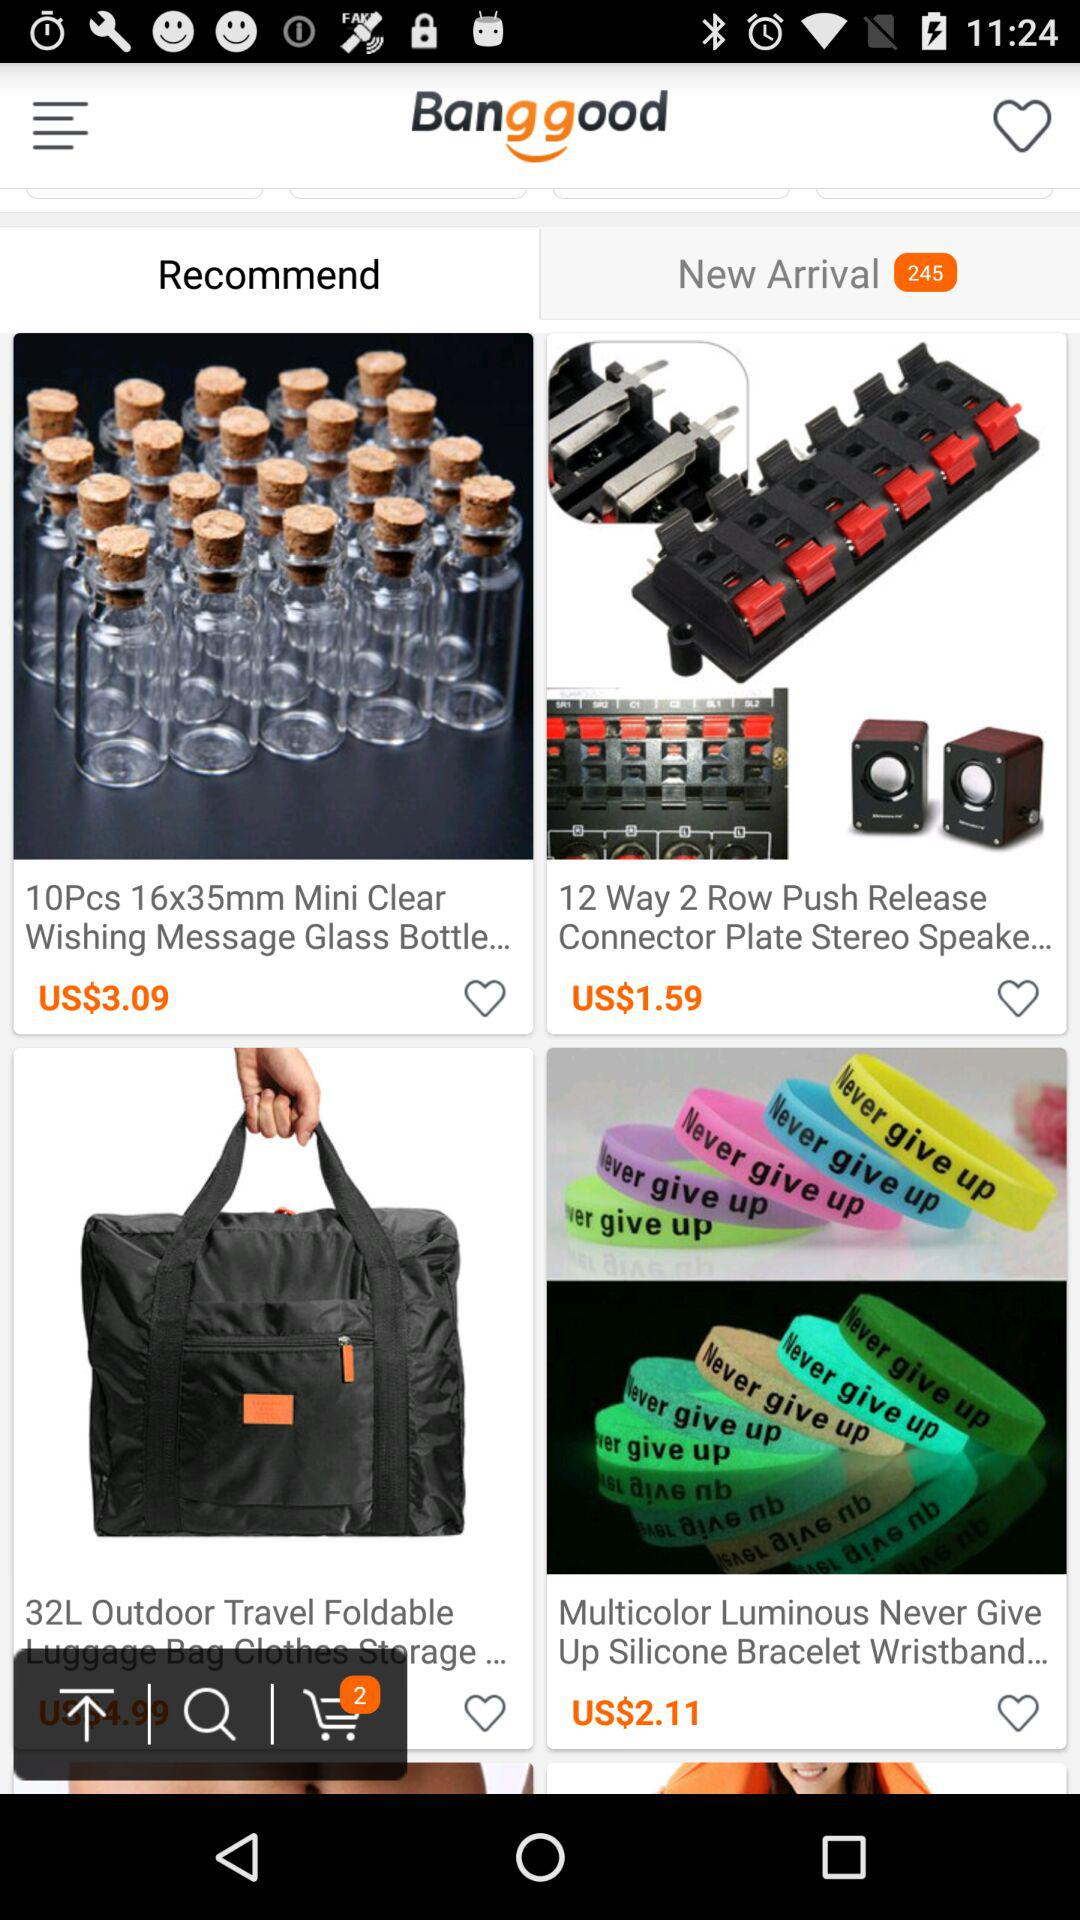How many items are in the shopping cart?
Answer the question using a single word or phrase. 2 